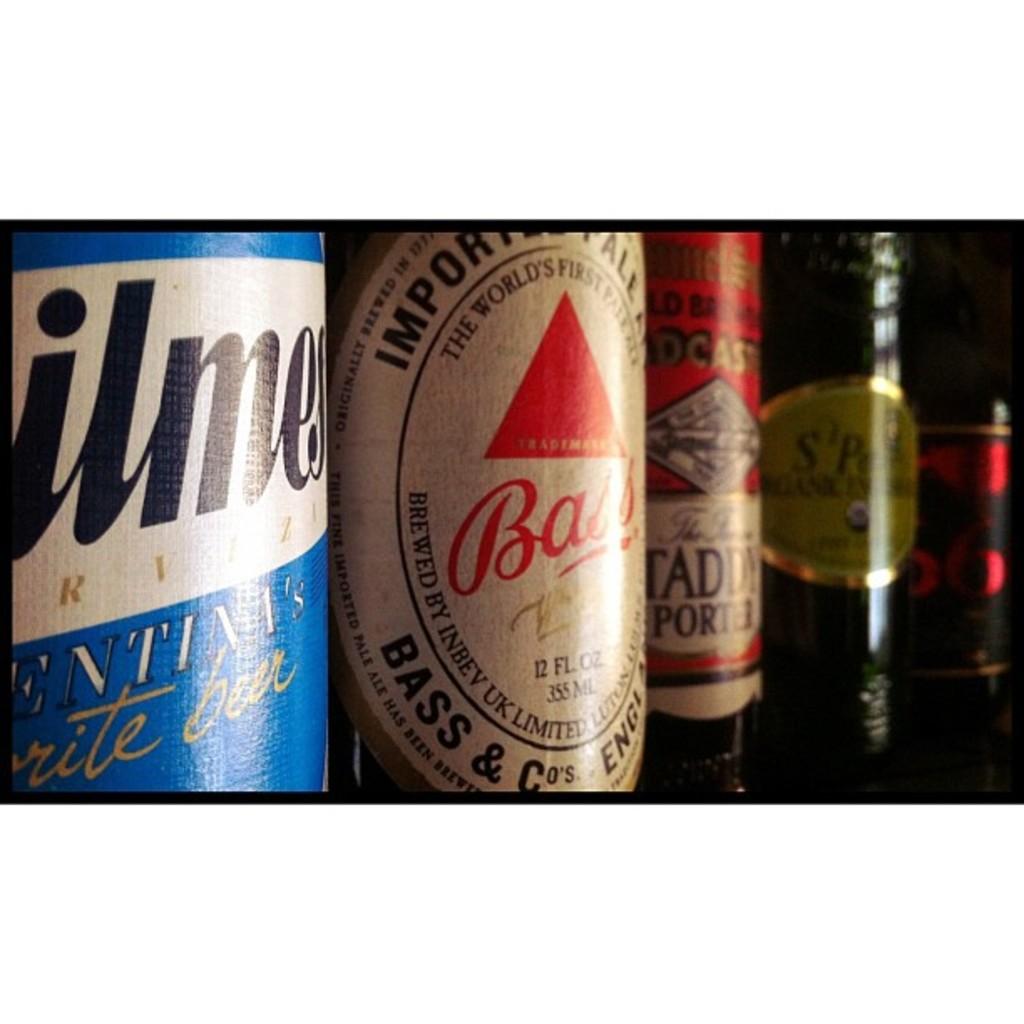What is the beer that is named after a fish?
Provide a short and direct response. Bass. What is the first letter in the red text of the bottle in the center?
Ensure brevity in your answer.  B. 